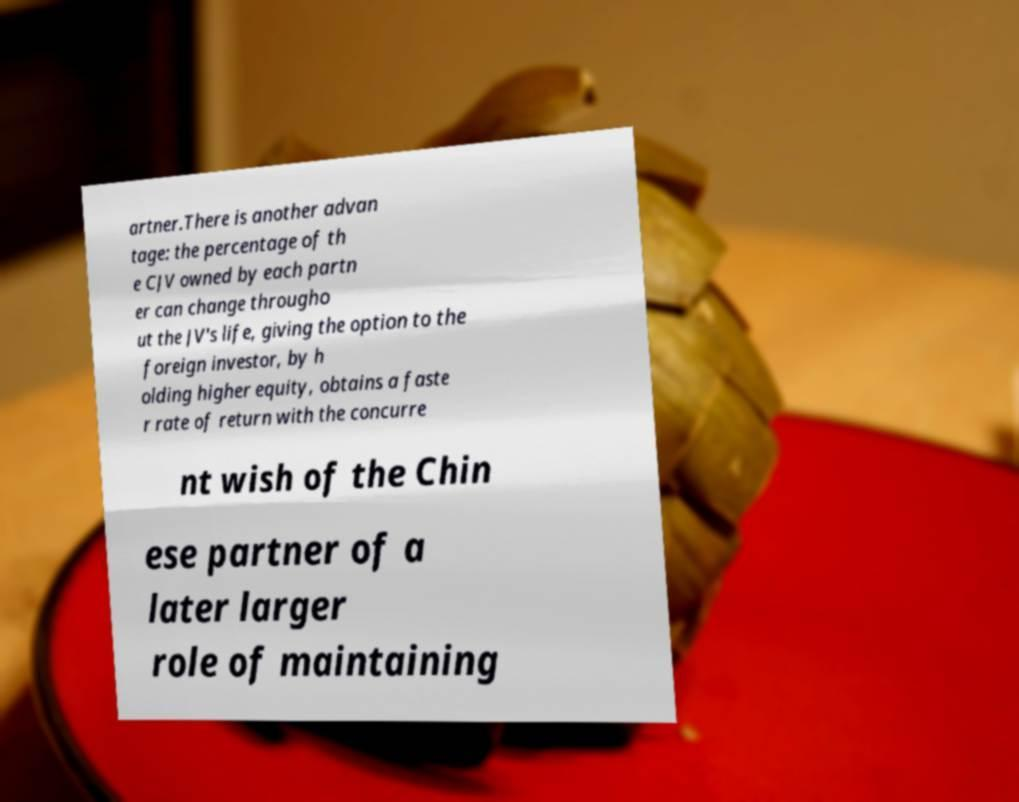What messages or text are displayed in this image? I need them in a readable, typed format. artner.There is another advan tage: the percentage of th e CJV owned by each partn er can change througho ut the JV's life, giving the option to the foreign investor, by h olding higher equity, obtains a faste r rate of return with the concurre nt wish of the Chin ese partner of a later larger role of maintaining 